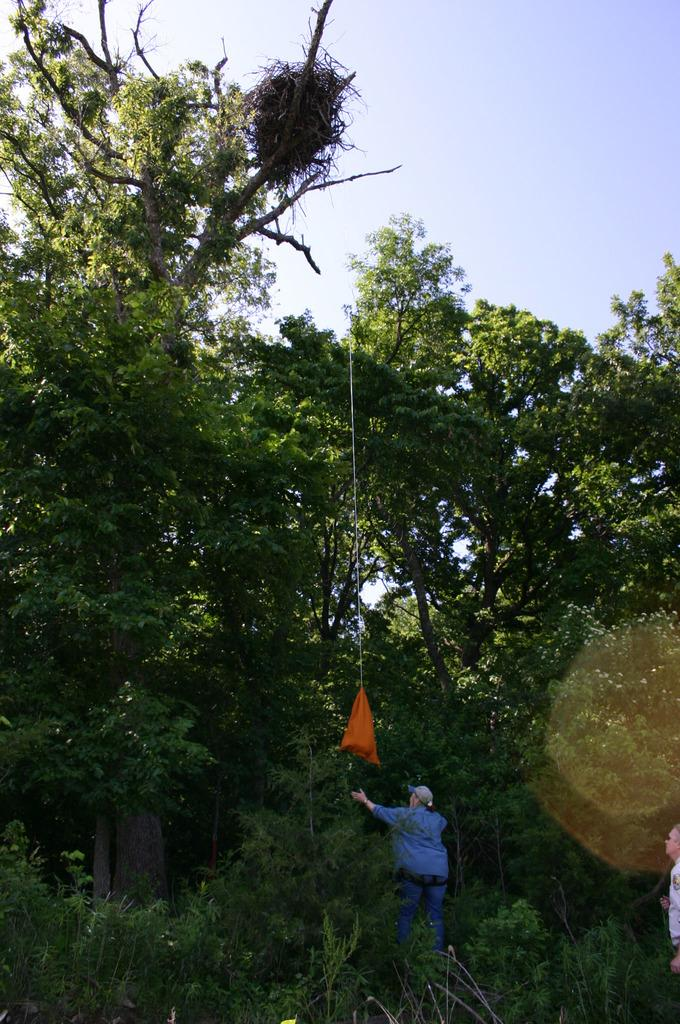What type of vegetation can be seen in the image? There are plants and trees in the image. How many people are present in the image? There are two people in the image. What is visible at the top of the image? The sky is visible at the top of the image. What type of bat can be seen flying in the image? There is no bat present in the image. What type of drug is being used by the people in the image? There is no indication of any drug use in the image. 